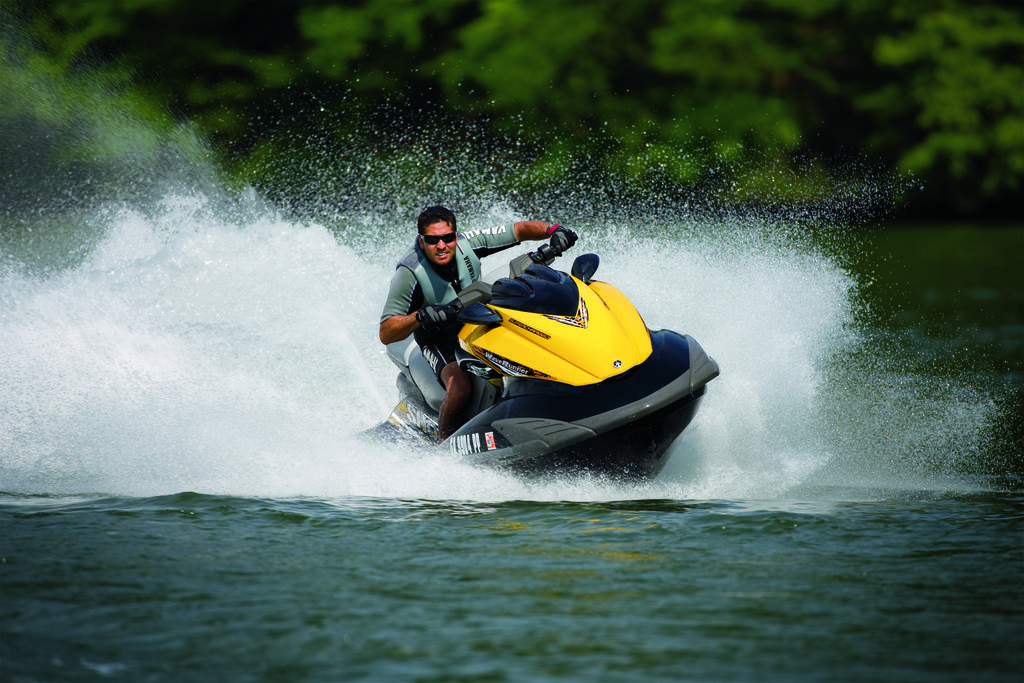What activity is the person in the image engaged in? The person is riding a jet ski in the image. Where is the jet ski located? The jet ski is on the water. What can be observed about the background of the image? The background of the image is dark. What type of ear is visible on the jet ski in the image? There is no ear present on the jet ski or the person riding it in the image. 